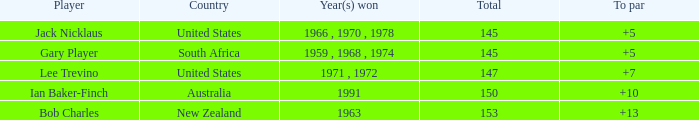Parse the table in full. {'header': ['Player', 'Country', 'Year(s) won', 'Total', 'To par'], 'rows': [['Jack Nicklaus', 'United States', '1966 , 1970 , 1978', '145', '+5'], ['Gary Player', 'South Africa', '1959 , 1968 , 1974', '145', '+5'], ['Lee Trevino', 'United States', '1971 , 1972', '147', '+7'], ['Ian Baker-Finch', 'Australia', '1991', '150', '+10'], ['Bob Charles', 'New Zealand', '1963', '153', '+13']]} What is the lowest To par of gary player, with more than 145 total? None. 